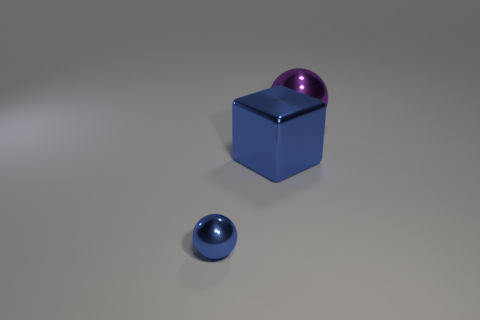What could be the purpose of arranging these objects like this? This arrangement seems to be a purposeful setup for either a display or a photography composition. It may be intended to showcase the shapes, colors, and reflective properties of the objects, or it could be part of a visual study of geometric forms and their interactions with light. 